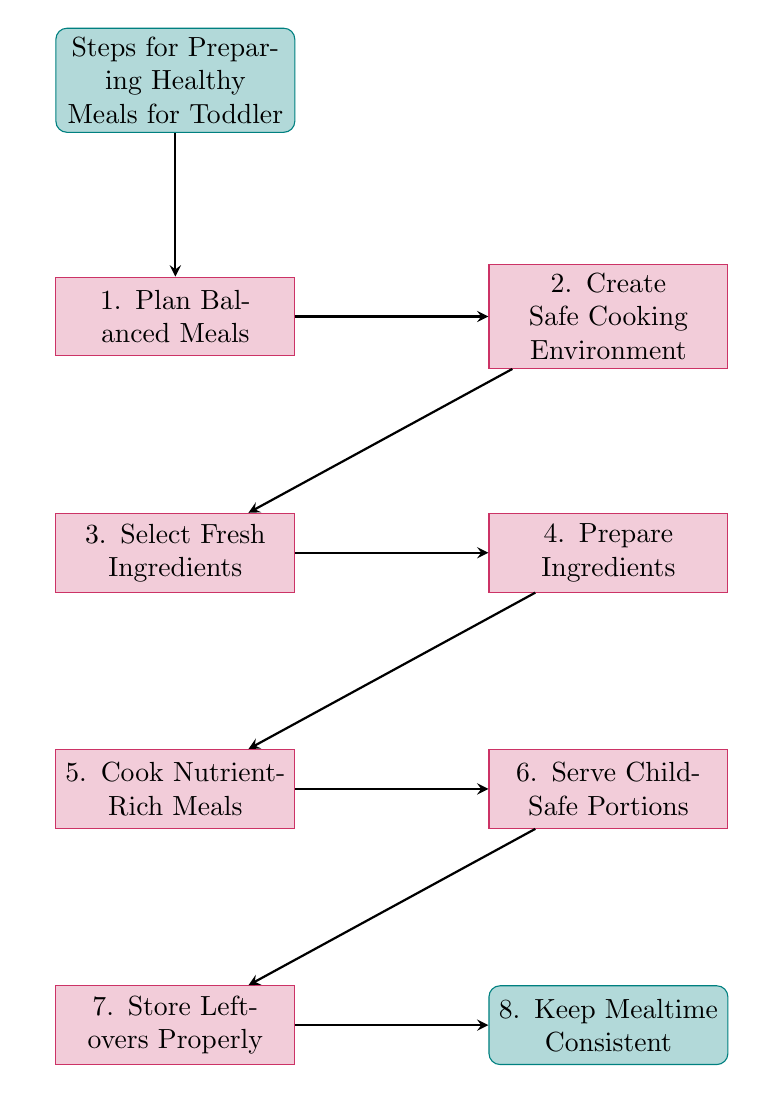What is the first step in preparing healthy meals for a toddler? The diagram lists the steps sequentially, with the first node following the title being "1. Plan Balanced Meals."
Answer: Plan Balanced Meals How many steps are there in total for preparing meals? The diagram consists of eight steps listed sequentially, which can be counted.
Answer: 8 What is the step that comes after selecting fresh ingredients? Following the flow from "3. Select Fresh Ingredients," the next step listed is "4. Prepare Ingredients."
Answer: Prepare Ingredients Which step emphasizes the importance of safety in the cooking environment? The second step, "2. Create Safe Cooking Environment," clearly addresses the need for safety when cooking.
Answer: Create Safe Cooking Environment What is the last step mentioned in the meal preparation process? The last node in the flow chart is "8. Keep Mealtime Consistent," indicating that it is the final step in the preparation process.
Answer: Keep Mealtime Consistent Explain why it’s important to use separate cutting boards. In step four, "Prepare Ingredients," it states the importance of using separate cutting boards for meats and veggies to avoid cross-contamination, thereby ensuring food safety for the toddler.
Answer: To avoid cross-contamination What cooking methods are recommended to retain nutrients? According to step five, "Cook Nutrient-Rich Meals," the recommended methods for cooking that retain nutrients are steaming, baking, or grilling.
Answer: Steaming, Baking, Grilling How should food be cut for the toddler? Step six, "Serve Child-Safe Portions," specifies that food should be cut into small, manageable pieces to prevent choking hazards for the toddler.
Answer: Small, manageable pieces What action should be taken with leftovers immediately after a meal? According to step seven, "Store Leftovers Properly," leftovers should be refrigerated or frozen immediately to maintain their freshness.
Answer: Refrigerate or freeze immediately 